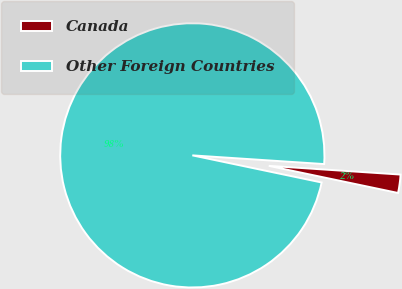Convert chart. <chart><loc_0><loc_0><loc_500><loc_500><pie_chart><fcel>Canada<fcel>Other Foreign Countries<nl><fcel>2.24%<fcel>97.76%<nl></chart> 